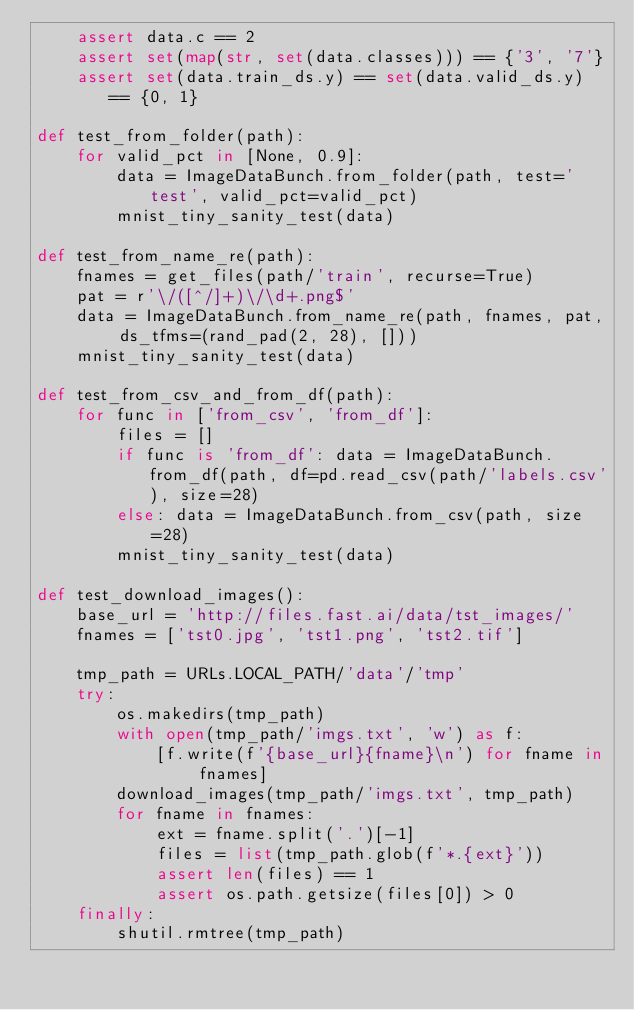<code> <loc_0><loc_0><loc_500><loc_500><_Python_>    assert data.c == 2
    assert set(map(str, set(data.classes))) == {'3', '7'}
    assert set(data.train_ds.y) == set(data.valid_ds.y) == {0, 1}

def test_from_folder(path):
    for valid_pct in [None, 0.9]:
        data = ImageDataBunch.from_folder(path, test='test', valid_pct=valid_pct)
        mnist_tiny_sanity_test(data)

def test_from_name_re(path):
    fnames = get_files(path/'train', recurse=True)
    pat = r'\/([^/]+)\/\d+.png$'
    data = ImageDataBunch.from_name_re(path, fnames, pat, ds_tfms=(rand_pad(2, 28), []))
    mnist_tiny_sanity_test(data)

def test_from_csv_and_from_df(path):
    for func in ['from_csv', 'from_df']:
        files = []
        if func is 'from_df': data = ImageDataBunch.from_df(path, df=pd.read_csv(path/'labels.csv'), size=28)
        else: data = ImageDataBunch.from_csv(path, size=28)
        mnist_tiny_sanity_test(data)

def test_download_images():
    base_url = 'http://files.fast.ai/data/tst_images/'
    fnames = ['tst0.jpg', 'tst1.png', 'tst2.tif']

    tmp_path = URLs.LOCAL_PATH/'data'/'tmp'
    try:
        os.makedirs(tmp_path)
        with open(tmp_path/'imgs.txt', 'w') as f:
            [f.write(f'{base_url}{fname}\n') for fname in fnames]
        download_images(tmp_path/'imgs.txt', tmp_path)
        for fname in fnames:
            ext = fname.split('.')[-1]
            files = list(tmp_path.glob(f'*.{ext}'))
            assert len(files) == 1
            assert os.path.getsize(files[0]) > 0
    finally:
        shutil.rmtree(tmp_path)</code> 